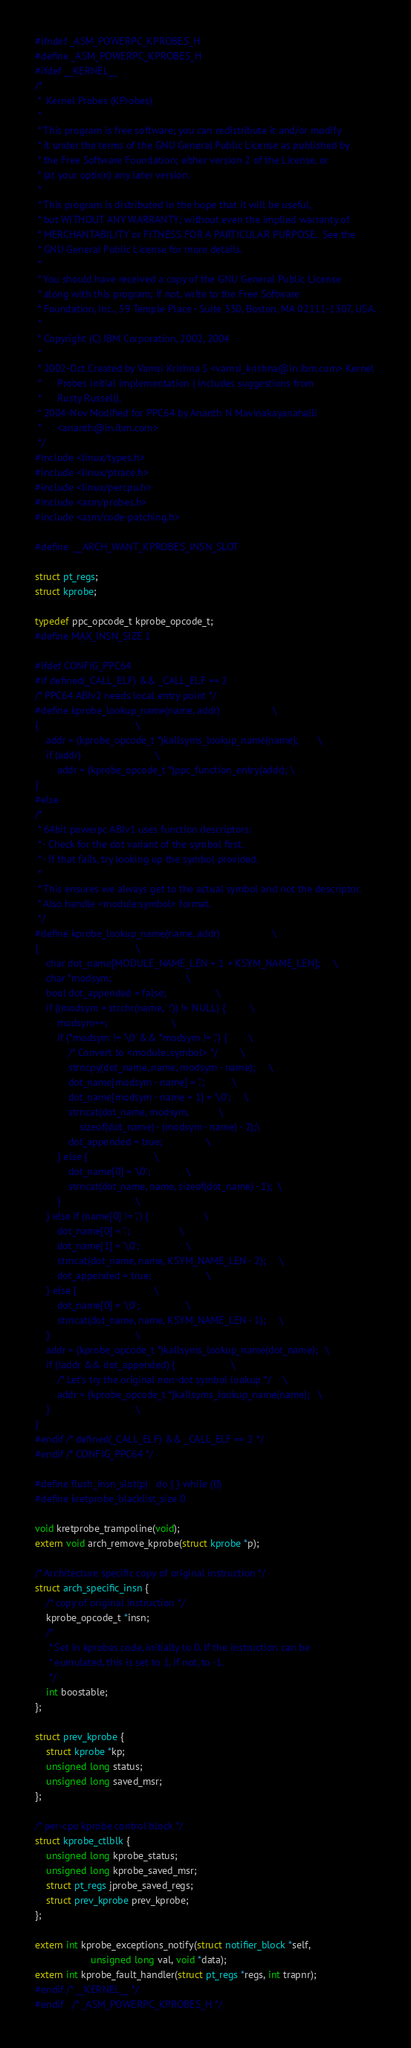<code> <loc_0><loc_0><loc_500><loc_500><_C_>#ifndef _ASM_POWERPC_KPROBES_H
#define _ASM_POWERPC_KPROBES_H
#ifdef __KERNEL__
/*
 *  Kernel Probes (KProbes)
 *
 * This program is free software; you can redistribute it and/or modify
 * it under the terms of the GNU General Public License as published by
 * the Free Software Foundation; either version 2 of the License, or
 * (at your option) any later version.
 *
 * This program is distributed in the hope that it will be useful,
 * but WITHOUT ANY WARRANTY; without even the implied warranty of
 * MERCHANTABILITY or FITNESS FOR A PARTICULAR PURPOSE.  See the
 * GNU General Public License for more details.
 *
 * You should have received a copy of the GNU General Public License
 * along with this program; if not, write to the Free Software
 * Foundation, Inc., 59 Temple Place - Suite 330, Boston, MA 02111-1307, USA.
 *
 * Copyright (C) IBM Corporation, 2002, 2004
 *
 * 2002-Oct	Created by Vamsi Krishna S <vamsi_krishna@in.ibm.com> Kernel
 *		Probes initial implementation ( includes suggestions from
 *		Rusty Russell).
 * 2004-Nov	Modified for PPC64 by Ananth N Mavinakayanahalli
 *		<ananth@in.ibm.com>
 */
#include <linux/types.h>
#include <linux/ptrace.h>
#include <linux/percpu.h>
#include <asm/probes.h>
#include <asm/code-patching.h>

#define  __ARCH_WANT_KPROBES_INSN_SLOT

struct pt_regs;
struct kprobe;

typedef ppc_opcode_t kprobe_opcode_t;
#define MAX_INSN_SIZE 1

#ifdef CONFIG_PPC64
#if defined(_CALL_ELF) && _CALL_ELF == 2
/* PPC64 ABIv2 needs local entry point */
#define kprobe_lookup_name(name, addr)					\
{									\
	addr = (kprobe_opcode_t *)kallsyms_lookup_name(name);		\
	if (addr)							\
		addr = (kprobe_opcode_t *)ppc_function_entry(addr);	\
}
#else
/*
 * 64bit powerpc ABIv1 uses function descriptors:
 * - Check for the dot variant of the symbol first.
 * - If that fails, try looking up the symbol provided.
 *
 * This ensures we always get to the actual symbol and not the descriptor.
 * Also handle <module:symbol> format.
 */
#define kprobe_lookup_name(name, addr)					\
{									\
	char dot_name[MODULE_NAME_LEN + 1 + KSYM_NAME_LEN];		\
	char *modsym;							\
	bool dot_appended = false;					\
	if ((modsym = strchr(name, ':')) != NULL) {			\
		modsym++;						\
		if (*modsym != '\0' && *modsym != '.') {		\
			/* Convert to <module:.symbol> */		\
			strncpy(dot_name, name, modsym - name);		\
			dot_name[modsym - name] = '.';			\
			dot_name[modsym - name + 1] = '\0';		\
			strncat(dot_name, modsym,			\
				sizeof(dot_name) - (modsym - name) - 2);\
			dot_appended = true;				\
		} else {						\
			dot_name[0] = '\0';				\
			strncat(dot_name, name, sizeof(dot_name) - 1);	\
		}							\
	} else if (name[0] != '.') {					\
		dot_name[0] = '.';					\
		dot_name[1] = '\0';					\
		strncat(dot_name, name, KSYM_NAME_LEN - 2);		\
		dot_appended = true;					\
	} else {							\
		dot_name[0] = '\0';					\
		strncat(dot_name, name, KSYM_NAME_LEN - 1);		\
	}								\
	addr = (kprobe_opcode_t *)kallsyms_lookup_name(dot_name);	\
	if (!addr && dot_appended) {					\
		/* Let's try the original non-dot symbol lookup	*/	\
		addr = (kprobe_opcode_t *)kallsyms_lookup_name(name);	\
	}								\
}
#endif /* defined(_CALL_ELF) && _CALL_ELF == 2 */
#endif /* CONFIG_PPC64 */

#define flush_insn_slot(p)	do { } while (0)
#define kretprobe_blacklist_size 0

void kretprobe_trampoline(void);
extern void arch_remove_kprobe(struct kprobe *p);

/* Architecture specific copy of original instruction */
struct arch_specific_insn {
	/* copy of original instruction */
	kprobe_opcode_t *insn;
	/*
	 * Set in kprobes code, initially to 0. If the instruction can be
	 * eumulated, this is set to 1, if not, to -1.
	 */
	int boostable;
};

struct prev_kprobe {
	struct kprobe *kp;
	unsigned long status;
	unsigned long saved_msr;
};

/* per-cpu kprobe control block */
struct kprobe_ctlblk {
	unsigned long kprobe_status;
	unsigned long kprobe_saved_msr;
	struct pt_regs jprobe_saved_regs;
	struct prev_kprobe prev_kprobe;
};

extern int kprobe_exceptions_notify(struct notifier_block *self,
					unsigned long val, void *data);
extern int kprobe_fault_handler(struct pt_regs *regs, int trapnr);
#endif /* __KERNEL__ */
#endif	/* _ASM_POWERPC_KPROBES_H */
</code> 